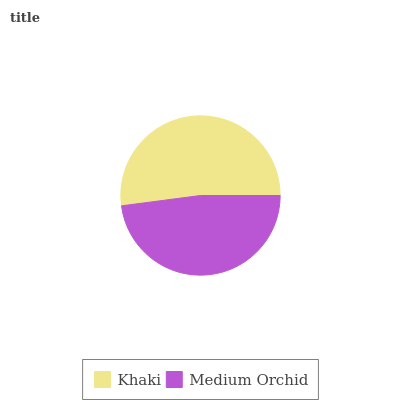Is Medium Orchid the minimum?
Answer yes or no. Yes. Is Khaki the maximum?
Answer yes or no. Yes. Is Medium Orchid the maximum?
Answer yes or no. No. Is Khaki greater than Medium Orchid?
Answer yes or no. Yes. Is Medium Orchid less than Khaki?
Answer yes or no. Yes. Is Medium Orchid greater than Khaki?
Answer yes or no. No. Is Khaki less than Medium Orchid?
Answer yes or no. No. Is Khaki the high median?
Answer yes or no. Yes. Is Medium Orchid the low median?
Answer yes or no. Yes. Is Medium Orchid the high median?
Answer yes or no. No. Is Khaki the low median?
Answer yes or no. No. 